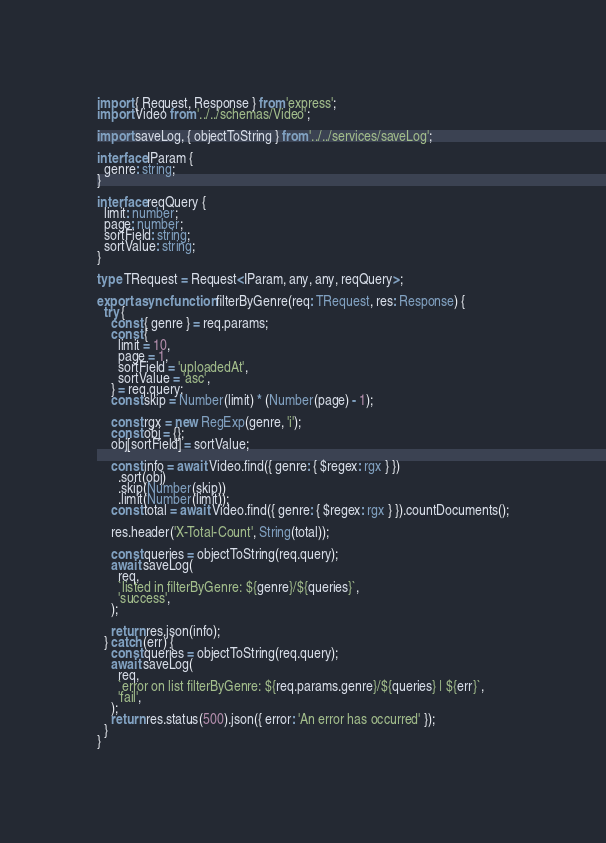<code> <loc_0><loc_0><loc_500><loc_500><_TypeScript_>import { Request, Response } from 'express';
import Video from '../../schemas/Video';

import saveLog, { objectToString } from '../../services/saveLog';

interface IParam {
  genre: string;
}

interface reqQuery {
  limit: number;
  page: number;
  sortField: string;
  sortValue: string;
}

type TRequest = Request<IParam, any, any, reqQuery>;

export async function filterByGenre(req: TRequest, res: Response) {
  try {
    const { genre } = req.params;
    const {
      limit = 10,
      page = 1,
      sortField = 'uploadedAt',
      sortValue = 'asc',
    } = req.query;
    const skip = Number(limit) * (Number(page) - 1);

    const rgx = new RegExp(genre, 'i');
    const obj = {};
    obj[sortField] = sortValue;

    const info = await Video.find({ genre: { $regex: rgx } })
      .sort(obj)
      .skip(Number(skip))
      .limit(Number(limit));
    const total = await Video.find({ genre: { $regex: rgx } }).countDocuments();

    res.header('X-Total-Count', String(total));

    const queries = objectToString(req.query);
    await saveLog(
      req,
      `listed in filterByGenre: ${genre}/${queries}`,
      'success',
    );

    return res.json(info);
  } catch (err) {
    const queries = objectToString(req.query);
    await saveLog(
      req,
      `error on list filterByGenre: ${req.params.genre}/${queries} | ${err}`,
      'fail',
    );
    return res.status(500).json({ error: 'An error has occurred' });
  }
}
</code> 